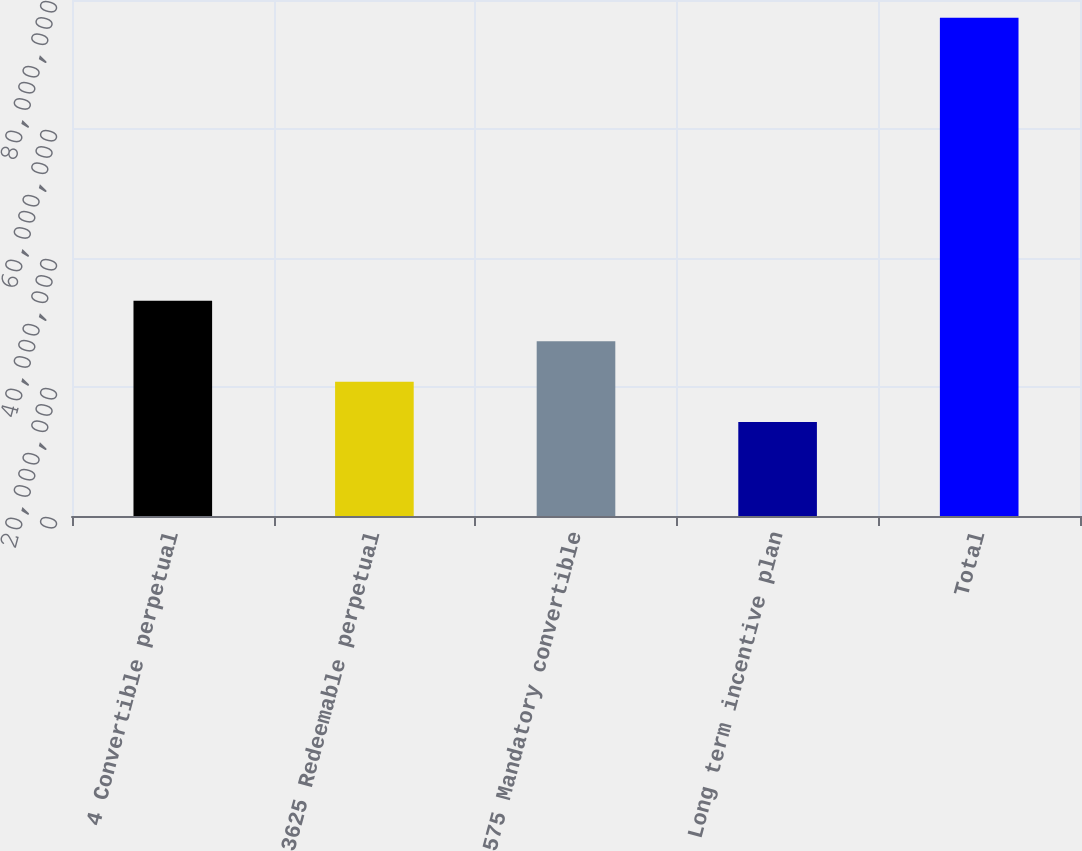Convert chart to OTSL. <chart><loc_0><loc_0><loc_500><loc_500><bar_chart><fcel>4 Convertible perpetual<fcel>3625 Redeemable perpetual<fcel>575 Mandatory convertible<fcel>Long term incentive plan<fcel>Total<nl><fcel>3.33673e+07<fcel>2.08329e+07<fcel>2.71001e+07<fcel>1.45657e+07<fcel>7.72377e+07<nl></chart> 